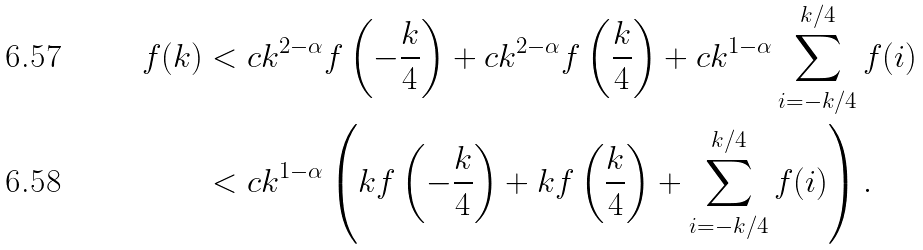<formula> <loc_0><loc_0><loc_500><loc_500>f ( k ) & < c k ^ { 2 - \alpha } f \left ( - \frac { k } { 4 } \right ) + c k ^ { 2 - \alpha } f \left ( \frac { k } { 4 } \right ) + c k ^ { 1 - \alpha } \sum _ { i = - k / 4 } ^ { k / 4 } f ( i ) \\ & < c k ^ { 1 - \alpha } \left ( k f \left ( - \frac { k } { 4 } \right ) + k f \left ( \frac { k } { 4 } \right ) + \sum _ { i = - k / 4 } ^ { k / 4 } f ( i ) \right ) .</formula> 